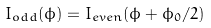<formula> <loc_0><loc_0><loc_500><loc_500>I _ { o d d } ( \phi ) = I _ { e v e n } ( \phi + \phi _ { 0 } / 2 )</formula> 